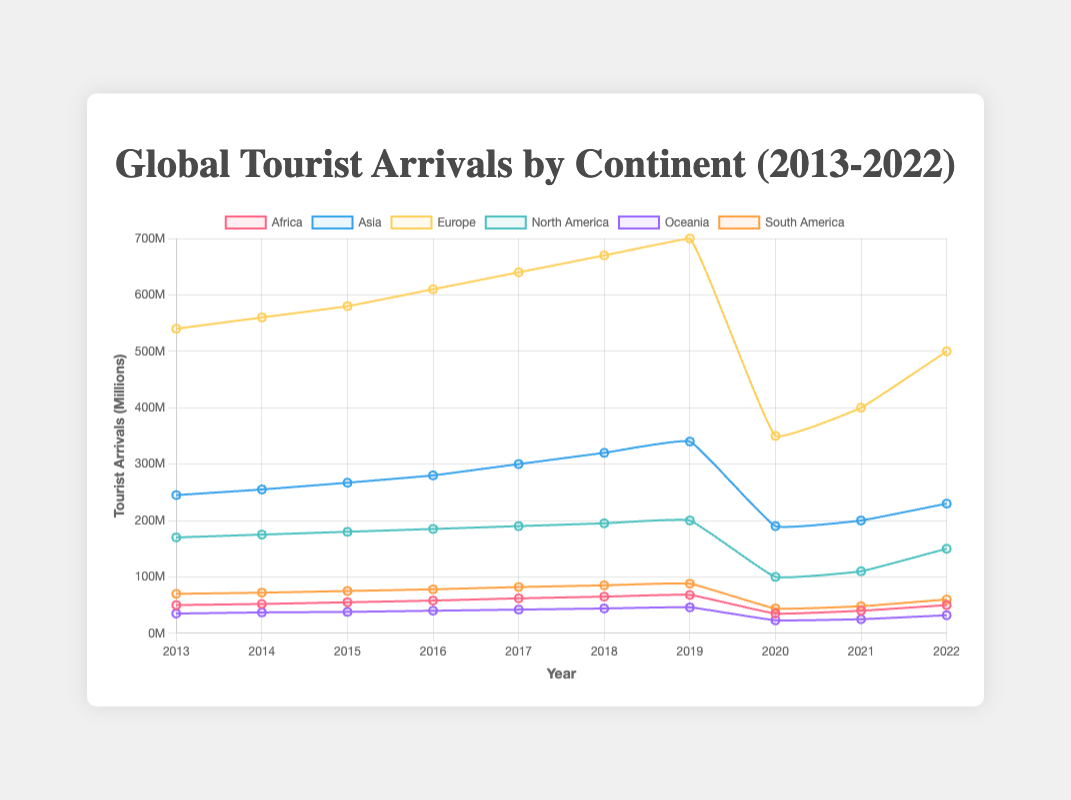What is the trend in tourist arrivals in Europe from 2013 to 2022? The line for Europe shows a steady increase in tourist arrivals from 540 million in 2013 to 700 million in 2019, a sharp decline to 350 million in 2020, followed by a gradual recovery to 500 million in 2022.
Answer: Steady increase, sharp decline, gradual recovery Which continent experienced the largest drop in tourist arrivals in 2020? By comparing the values for each continent from 2019 to 2020, Europe shows the largest drop from 700 million to 350 million, a decrease of 350 million.
Answer: Europe What is the total number of tourist arrivals in Africa from 2013 to 2018? Sum the values for Africa from 2013 (50 million) to 2018 (65 million): 50 + 52 + 55 + 58 + 62 + 65 = 342 million.
Answer: 342 million In which year did Asia experience its highest number of tourist arrivals, and what was the value? The line for Asia peaks in 2019 with a value of 340 million.
Answer: 2019, 340 million Compare the recovery in tourist arrivals between North America and South America from 2020 to 2022. Which continent had a greater recovery and by how much? North America recovered from 100 million in 2020 to 150 million in 2022, an increase of 50 million. South America recovered from 44 million in 2020 to 60 million in 2022, an increase of 16 million. Therefore, North America had a greater recovery by 34 million.
Answer: North America, by 34 million What is the average number of tourist arrivals in Oceania over the decade? Sum the values for Oceania from 2013 to 2022: 35 + 37 + 38 + 40 + 42 + 44 + 46 + 23 + 25 + 32 = 362 million. Dividing by 10 (number of years), the average is 362/10 = 36.2 million.
Answer: 36.2 million Between 2015 and 2017, which continent saw the highest increase in tourist arrivals? Calculate the difference in tourist arrivals for each continent between 2015 and 2017: Africa (62 - 55 = 7 million), Asia (300 - 267 = 33 million), Europe (640 - 580 = 60 million), North America (190 - 180 = 10 million), Oceania (42 - 38 = 4 million), South America (82 - 75 = 7 million). Europe had the highest increase of 60 million.
Answer: Europe Which continent had the smallest decrease in tourist arrivals from 2019 to 2020, and what was the value? By comparing the values for each continent from 2019 to 2020: Africa (68 - 35 = 33 million), Asia (340 - 190 = 150 million), Europe (700 - 350 = 350 million), North America (200 - 100 = 100 million), Oceania (46 - 23 = 23 million), South America (88 - 44 = 44 million). Oceania had the smallest decrease of 23 million.
Answer: Oceania, 23 million What were the tourist arrivals in South America in 2015, and how does it compare to the 2022 level? In 2015, South America had 75 million tourist arrivals. In 2022, it had 60 million. To compare, 2022's value is 15 million less than 2015's value.
Answer: 75 million, 15 million less 